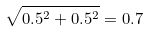<formula> <loc_0><loc_0><loc_500><loc_500>\sqrt { 0 . 5 ^ { 2 } + 0 . 5 ^ { 2 } } = 0 . 7</formula> 